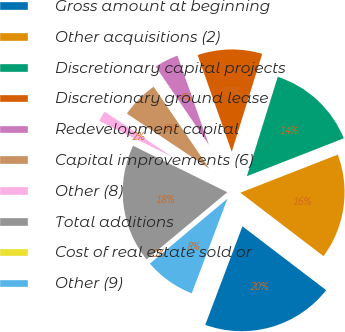<chart> <loc_0><loc_0><loc_500><loc_500><pie_chart><fcel>Gross amount at beginning<fcel>Other acquisitions (2)<fcel>Discretionary capital projects<fcel>Discretionary ground lease<fcel>Redevelopment capital<fcel>Capital improvements (6)<fcel>Other (8)<fcel>Total additions<fcel>Cost of real estate sold or<fcel>Other (9)<nl><fcel>20.37%<fcel>16.3%<fcel>14.27%<fcel>10.2%<fcel>4.1%<fcel>6.14%<fcel>2.07%<fcel>18.34%<fcel>0.04%<fcel>8.17%<nl></chart> 